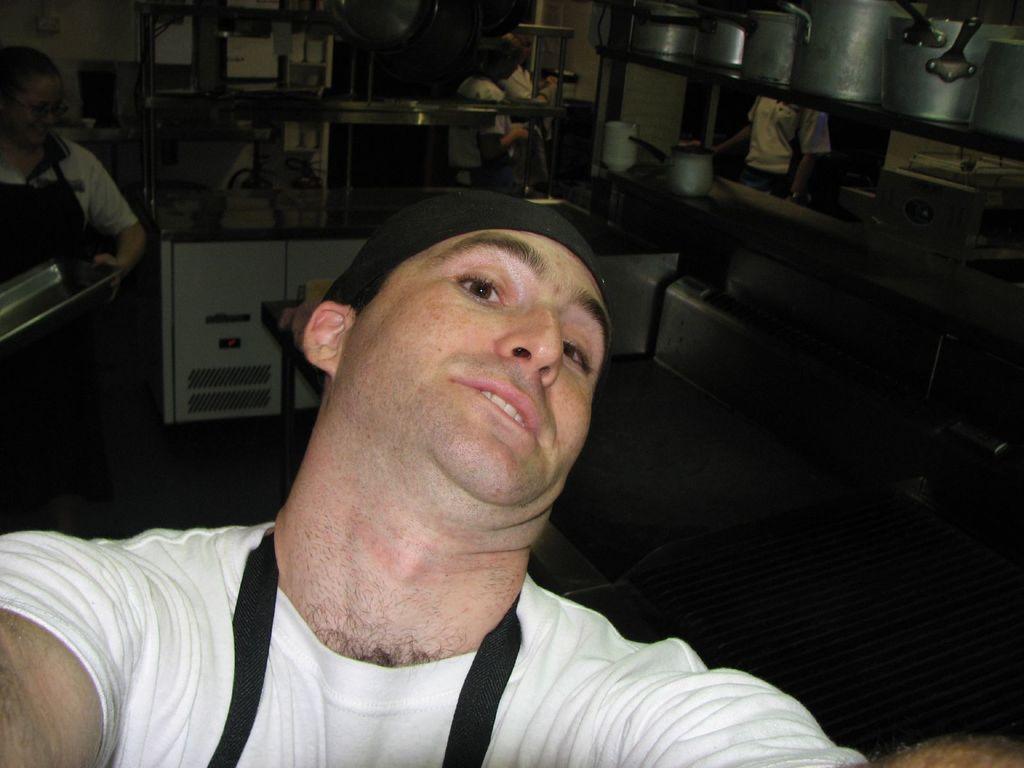How would you summarize this image in a sentence or two? In this picture we can see some people, on the right side there are shelves, we can see some jars present on this shelf, we can see handles of these jars, there is a counter top on the middle, int he background there is a wall, a woman on the left side is holding a tray. 